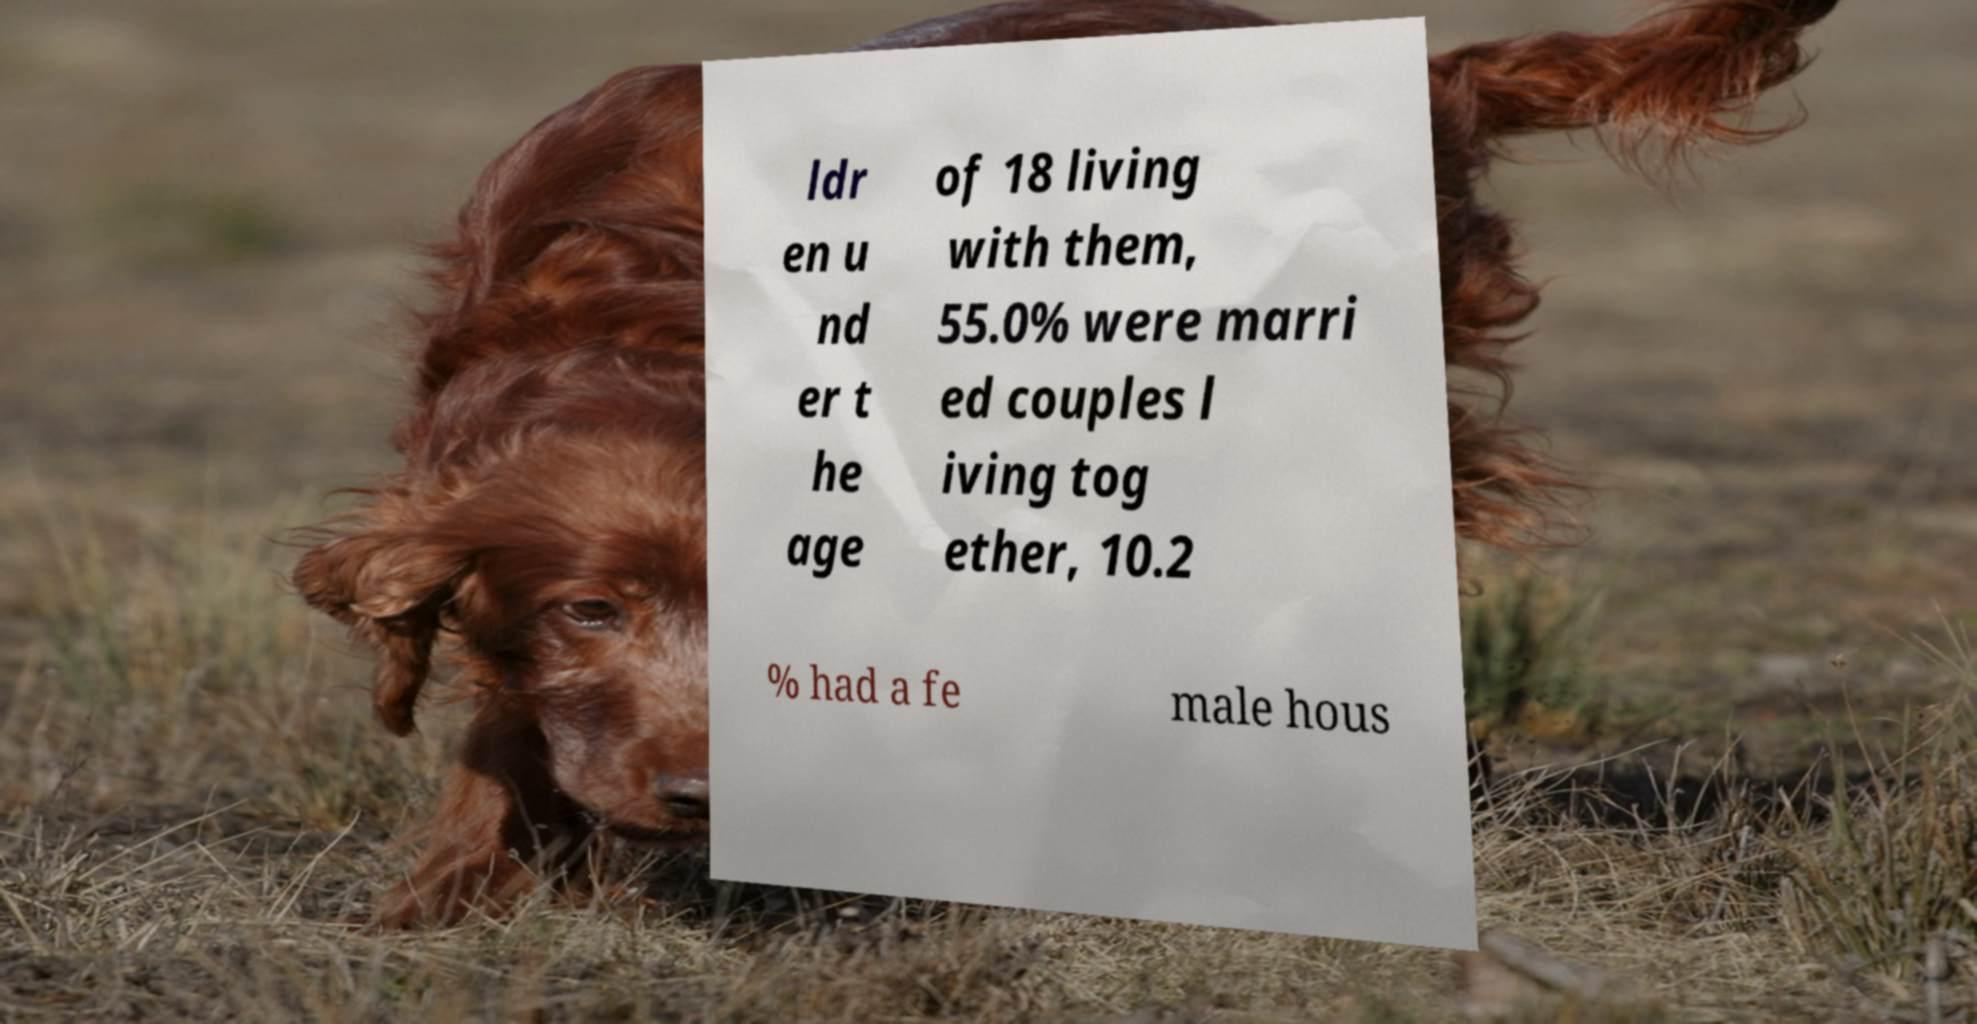There's text embedded in this image that I need extracted. Can you transcribe it verbatim? ldr en u nd er t he age of 18 living with them, 55.0% were marri ed couples l iving tog ether, 10.2 % had a fe male hous 